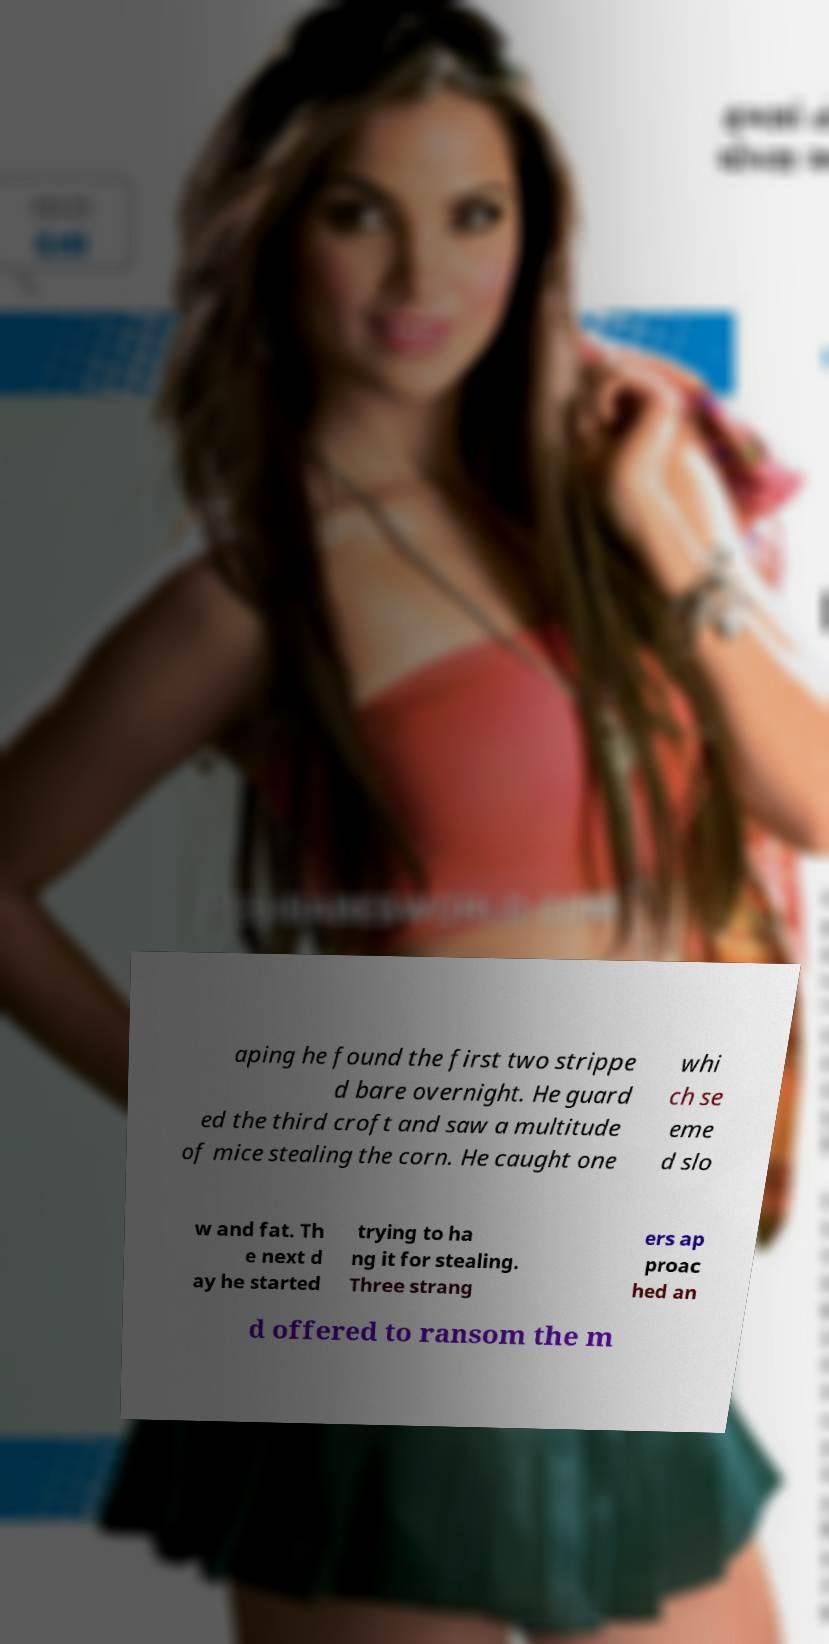I need the written content from this picture converted into text. Can you do that? aping he found the first two strippe d bare overnight. He guard ed the third croft and saw a multitude of mice stealing the corn. He caught one whi ch se eme d slo w and fat. Th e next d ay he started trying to ha ng it for stealing. Three strang ers ap proac hed an d offered to ransom the m 